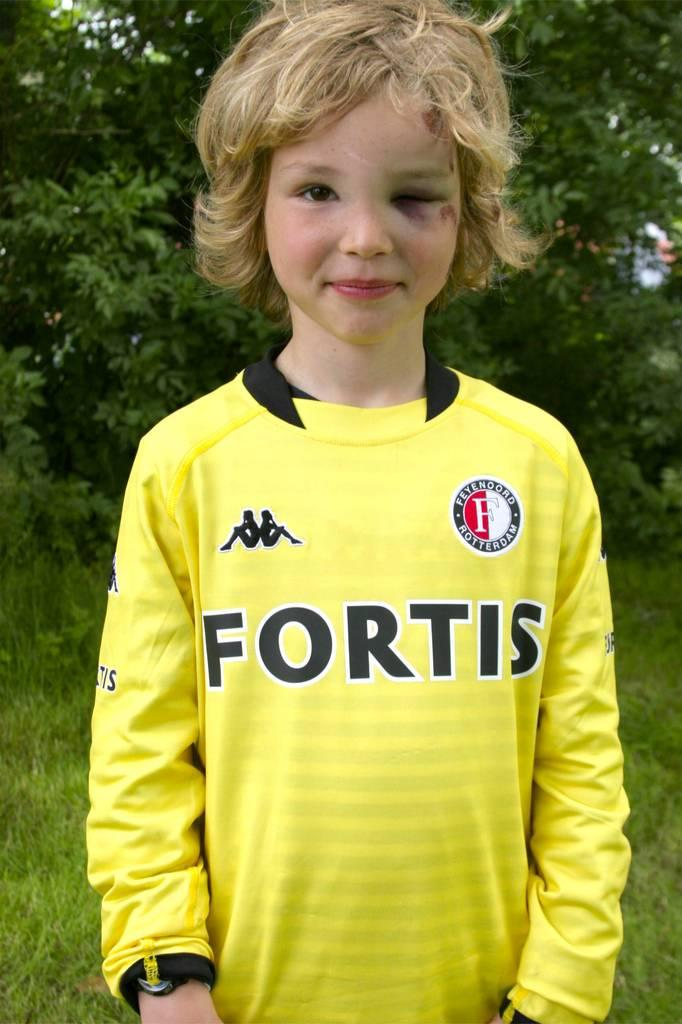<image>
Share a concise interpretation of the image provided. A blonde child wearing a yellow FORTIS shirt has a black left eye. 